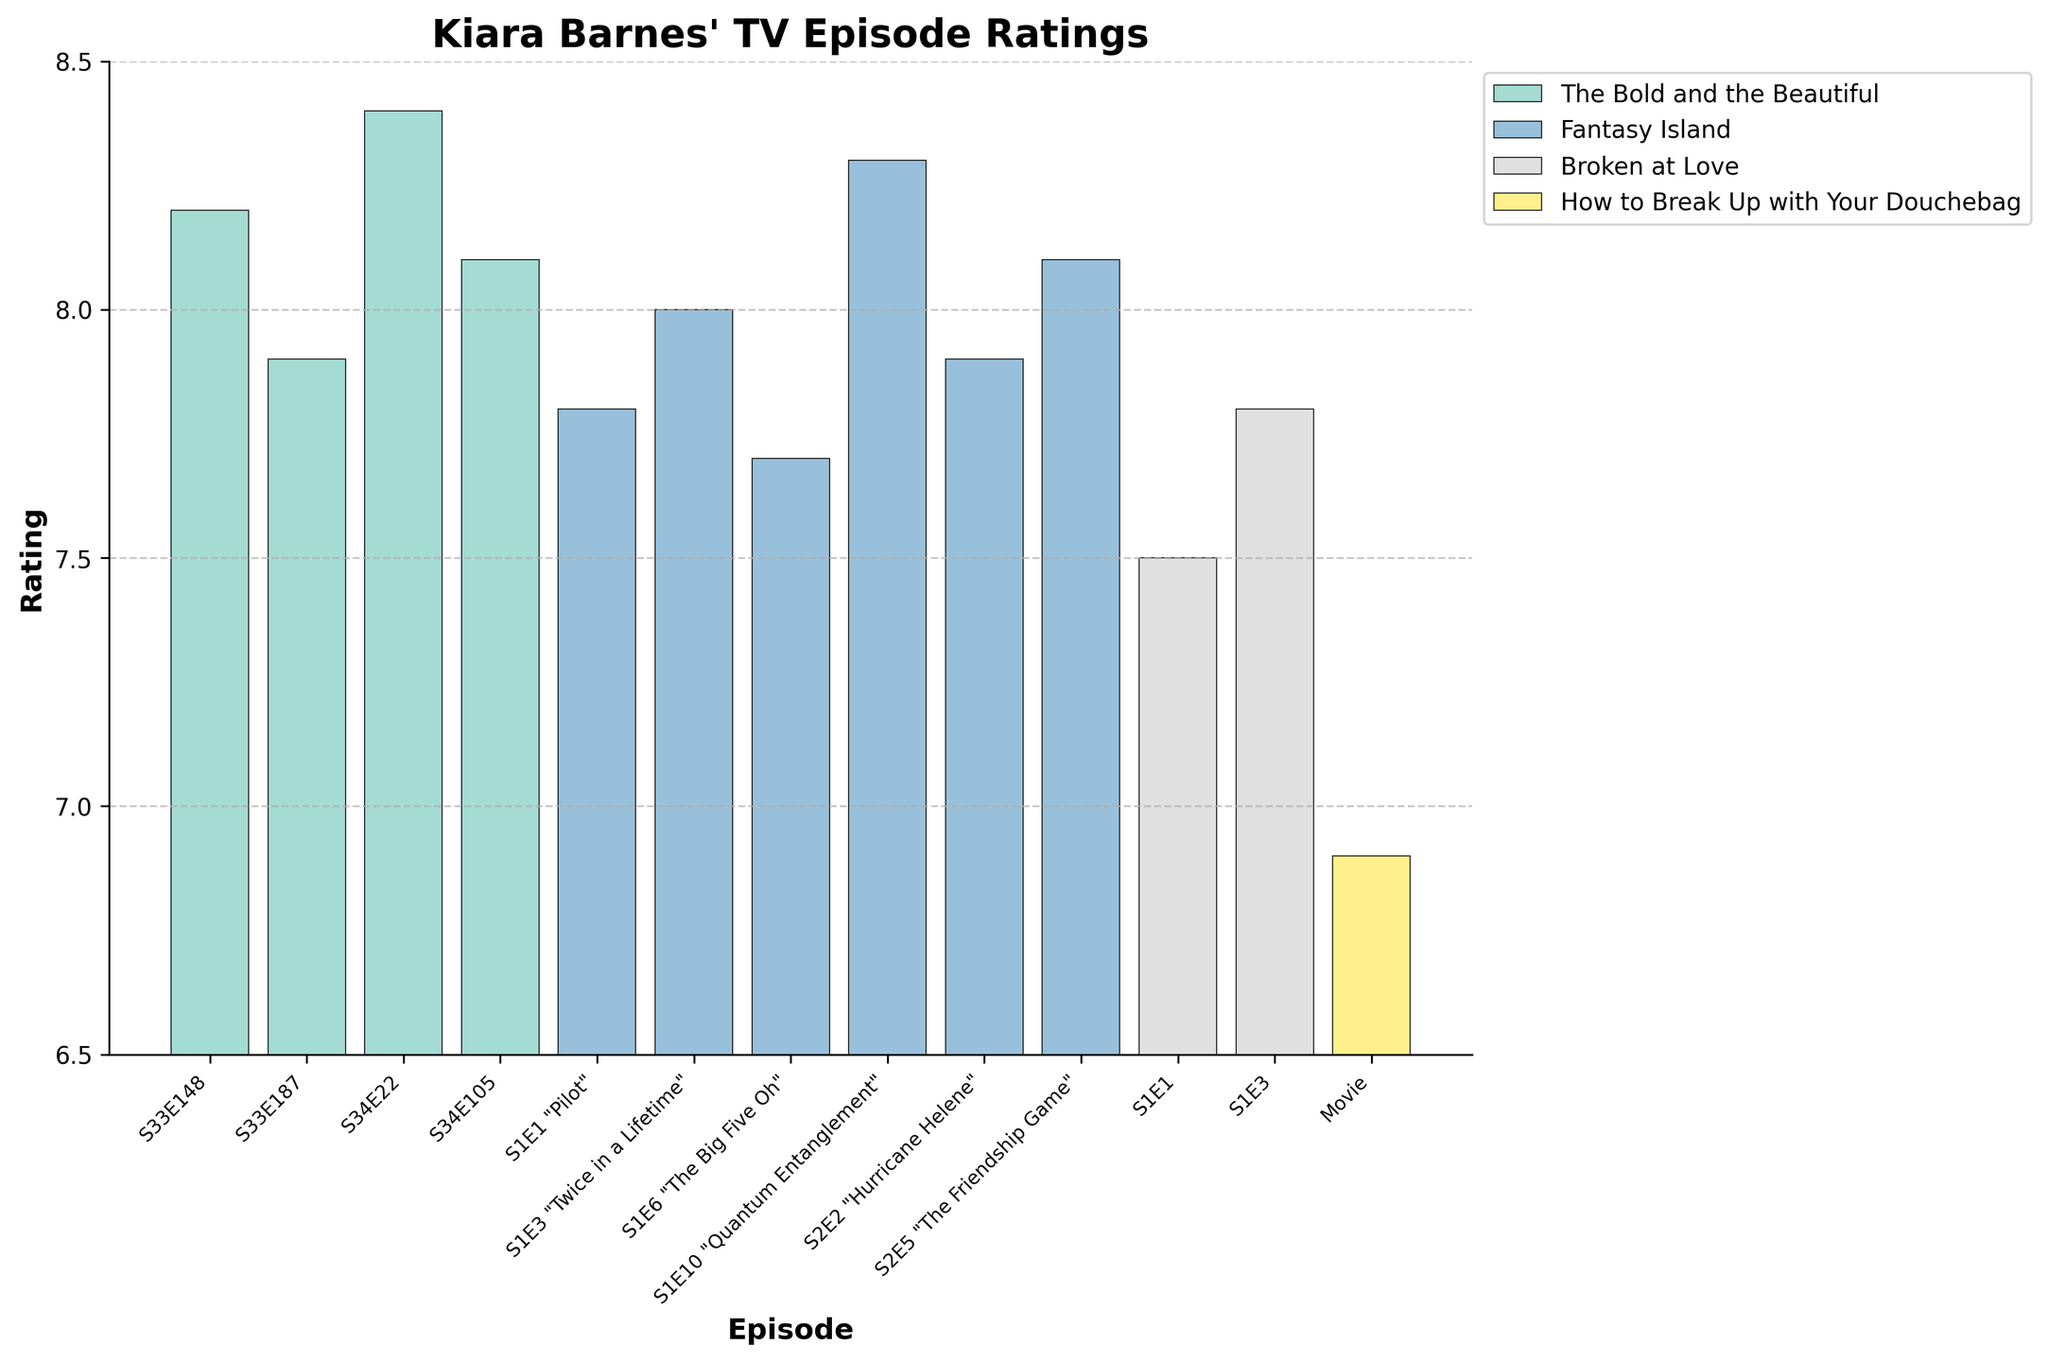Which episode featuring Kiara Barnes has the highest rating? Examine the heights of the bars in the bar chart and identify the tallest bar, which represents the highest rating. This corresponds to the episode "The Bold and the Beautiful S34E22" with a rating of 8.4.
Answer: The Bold and the Beautiful S34E22 How many episodes have a rating of 8.0 or higher? Count the number of bars that reach the 8.0 rating mark or higher. There are 8 episodes that meet this criterion: The Bold and the Beautiful S33E148, The Bold and the Beautiful S34E22, The Bold and the Beautiful S34E105, Fantasy Island S1E3, Fantasy Island S1E10, Fantasy Island S2E5, The Bold and the Beautiful S34E105, and The Bold and the Beautiful S34E22.
Answer: 8 Which series has the lowest average rating? Calculate the average rating for each series by summing the ratings of its episodes and dividing by the number of episodes. Compare these averages. "How to Break Up with Your Douchebag" has only one entry with a rating of 6.9, which is the lowest among the series.
Answer: How to Break Up with Your Douchebag Are there more episodes rated above 8.0 in "The Bold and the Beautiful" or "Fantasy Island"? Count the number of episodes rated above 8.0 for each series: 
"The Bold and the Beautiful" has 3 episodes (S33E148, S34E22, and S34E105).
"Fantasy Island" has 3 episodes (S1E3, S1E10, and S2E5).
Since both have 3, neither has more.
Answer: Neither What is the difference between the highest and lowest ratings of "Fantasy Island"? Identify the highest rating in "Fantasy Island" as 8.3 (S1E10) and the lowest as 7.7 (S1E6). Subtract the lowest rating from the highest: 8.3 - 7.7 = 0.6.
Answer: 0.6 How does the rating of "Broken at Love S1E1" compare to "Fantasy Island S1E6"? Check the heights of the bars for these two episodes. "Broken at Love S1E1" is rated 7.5, and "Fantasy Island S1E6" is rated 7.7. "Fantasy Island S1E6" has a higher rating.
Answer: Fantasy Island S1E6 is higher What is the average rating of "The Bold and the Beautiful" episodes? Sum the ratings of all episodes of "The Bold and the Beautiful" and divide by the number of episodes. The episodes are S33E148 (8.2), S33E187 (7.9), S34E22 (8.4), and S34E105 (8.1). Average = (8.2 + 7.9 + 8.4 + 8.1) / 4 = 8.15.
Answer: 8.15 Which episodes have a rating between 7.8 and 8.0? Identify the bars that fall within this range: "The Bold and the Beautiful S33E187" (7.9), "Fantasy Island S1E1" (7.8), "Fantasy Island S2E2" (7.9), and "Broken at Love S1E3" (7.8).
Answer: The Bold and the Beautiful S33E187, Fantasy Island S1E1, Fantasy Island S2E2, Broken at Love S1E3 